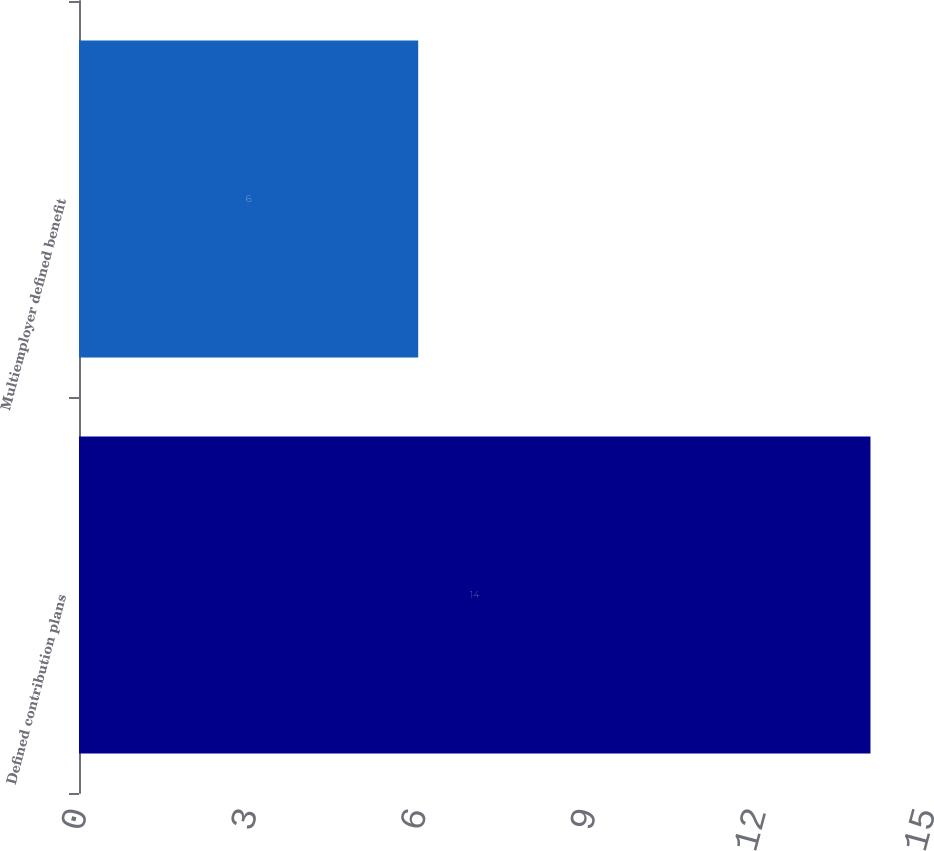<chart> <loc_0><loc_0><loc_500><loc_500><bar_chart><fcel>Defined contribution plans<fcel>Multiemployer defined benefit<nl><fcel>14<fcel>6<nl></chart> 